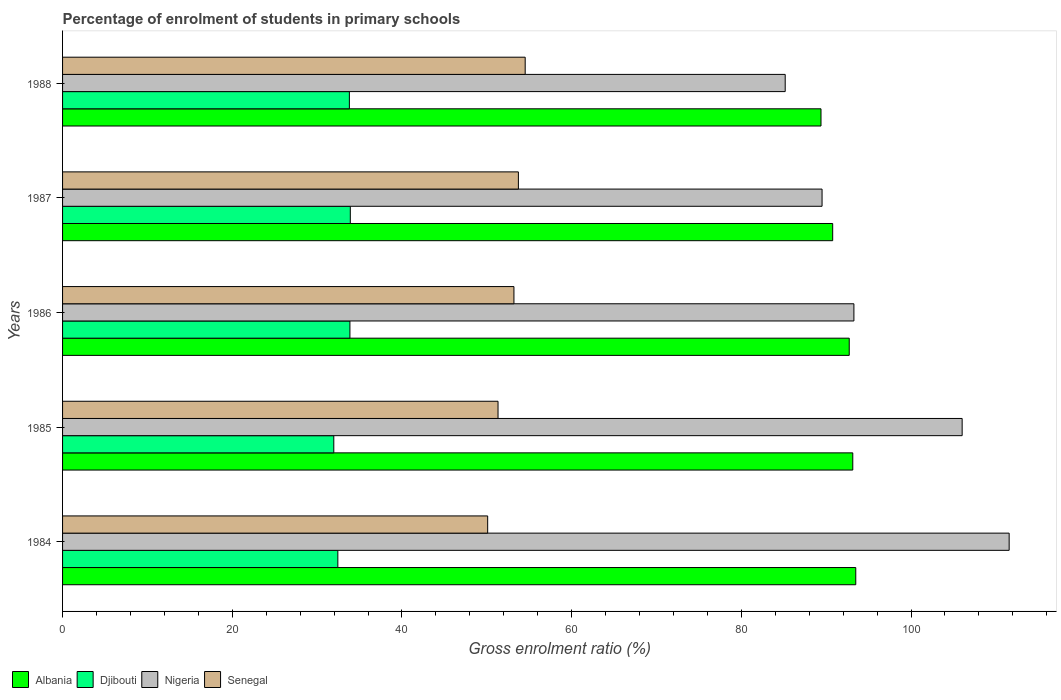How many different coloured bars are there?
Your answer should be compact. 4. Are the number of bars on each tick of the Y-axis equal?
Give a very brief answer. Yes. How many bars are there on the 4th tick from the top?
Your response must be concise. 4. What is the label of the 1st group of bars from the top?
Provide a succinct answer. 1988. What is the percentage of students enrolled in primary schools in Senegal in 1985?
Your response must be concise. 51.32. Across all years, what is the maximum percentage of students enrolled in primary schools in Nigeria?
Give a very brief answer. 111.57. Across all years, what is the minimum percentage of students enrolled in primary schools in Albania?
Ensure brevity in your answer.  89.39. What is the total percentage of students enrolled in primary schools in Senegal in the graph?
Your answer should be very brief. 262.87. What is the difference between the percentage of students enrolled in primary schools in Nigeria in 1984 and that in 1987?
Your answer should be very brief. 22.05. What is the difference between the percentage of students enrolled in primary schools in Djibouti in 1984 and the percentage of students enrolled in primary schools in Nigeria in 1986?
Keep it short and to the point. -60.82. What is the average percentage of students enrolled in primary schools in Senegal per year?
Provide a short and direct response. 52.57. In the year 1986, what is the difference between the percentage of students enrolled in primary schools in Djibouti and percentage of students enrolled in primary schools in Albania?
Give a very brief answer. -58.85. What is the ratio of the percentage of students enrolled in primary schools in Nigeria in 1985 to that in 1986?
Provide a short and direct response. 1.14. Is the percentage of students enrolled in primary schools in Djibouti in 1986 less than that in 1987?
Give a very brief answer. Yes. What is the difference between the highest and the second highest percentage of students enrolled in primary schools in Djibouti?
Make the answer very short. 0.05. What is the difference between the highest and the lowest percentage of students enrolled in primary schools in Senegal?
Offer a very short reply. 4.42. Is the sum of the percentage of students enrolled in primary schools in Nigeria in 1984 and 1988 greater than the maximum percentage of students enrolled in primary schools in Senegal across all years?
Ensure brevity in your answer.  Yes. What does the 3rd bar from the top in 1987 represents?
Your answer should be very brief. Djibouti. What does the 3rd bar from the bottom in 1988 represents?
Your response must be concise. Nigeria. How many bars are there?
Ensure brevity in your answer.  20. Where does the legend appear in the graph?
Provide a succinct answer. Bottom left. How many legend labels are there?
Keep it short and to the point. 4. How are the legend labels stacked?
Ensure brevity in your answer.  Horizontal. What is the title of the graph?
Your answer should be compact. Percentage of enrolment of students in primary schools. Does "Burkina Faso" appear as one of the legend labels in the graph?
Offer a terse response. No. What is the label or title of the X-axis?
Make the answer very short. Gross enrolment ratio (%). What is the Gross enrolment ratio (%) of Albania in 1984?
Provide a short and direct response. 93.49. What is the Gross enrolment ratio (%) of Djibouti in 1984?
Provide a succinct answer. 32.44. What is the Gross enrolment ratio (%) in Nigeria in 1984?
Make the answer very short. 111.57. What is the Gross enrolment ratio (%) of Senegal in 1984?
Provide a short and direct response. 50.1. What is the Gross enrolment ratio (%) of Albania in 1985?
Offer a terse response. 93.13. What is the Gross enrolment ratio (%) of Djibouti in 1985?
Your response must be concise. 31.97. What is the Gross enrolment ratio (%) in Nigeria in 1985?
Make the answer very short. 106.03. What is the Gross enrolment ratio (%) of Senegal in 1985?
Ensure brevity in your answer.  51.32. What is the Gross enrolment ratio (%) in Albania in 1986?
Your answer should be very brief. 92.72. What is the Gross enrolment ratio (%) in Djibouti in 1986?
Ensure brevity in your answer.  33.87. What is the Gross enrolment ratio (%) of Nigeria in 1986?
Keep it short and to the point. 93.27. What is the Gross enrolment ratio (%) in Senegal in 1986?
Your response must be concise. 53.2. What is the Gross enrolment ratio (%) in Albania in 1987?
Keep it short and to the point. 90.77. What is the Gross enrolment ratio (%) in Djibouti in 1987?
Make the answer very short. 33.91. What is the Gross enrolment ratio (%) of Nigeria in 1987?
Keep it short and to the point. 89.51. What is the Gross enrolment ratio (%) in Senegal in 1987?
Provide a succinct answer. 53.72. What is the Gross enrolment ratio (%) in Albania in 1988?
Ensure brevity in your answer.  89.39. What is the Gross enrolment ratio (%) in Djibouti in 1988?
Make the answer very short. 33.8. What is the Gross enrolment ratio (%) of Nigeria in 1988?
Offer a terse response. 85.17. What is the Gross enrolment ratio (%) in Senegal in 1988?
Give a very brief answer. 54.53. Across all years, what is the maximum Gross enrolment ratio (%) in Albania?
Your answer should be compact. 93.49. Across all years, what is the maximum Gross enrolment ratio (%) in Djibouti?
Provide a succinct answer. 33.91. Across all years, what is the maximum Gross enrolment ratio (%) of Nigeria?
Your answer should be compact. 111.57. Across all years, what is the maximum Gross enrolment ratio (%) in Senegal?
Keep it short and to the point. 54.53. Across all years, what is the minimum Gross enrolment ratio (%) of Albania?
Offer a terse response. 89.39. Across all years, what is the minimum Gross enrolment ratio (%) in Djibouti?
Offer a very short reply. 31.97. Across all years, what is the minimum Gross enrolment ratio (%) in Nigeria?
Ensure brevity in your answer.  85.17. Across all years, what is the minimum Gross enrolment ratio (%) in Senegal?
Your response must be concise. 50.1. What is the total Gross enrolment ratio (%) in Albania in the graph?
Provide a short and direct response. 459.49. What is the total Gross enrolment ratio (%) of Djibouti in the graph?
Offer a terse response. 166. What is the total Gross enrolment ratio (%) in Nigeria in the graph?
Provide a succinct answer. 485.54. What is the total Gross enrolment ratio (%) of Senegal in the graph?
Your response must be concise. 262.87. What is the difference between the Gross enrolment ratio (%) of Albania in 1984 and that in 1985?
Provide a succinct answer. 0.35. What is the difference between the Gross enrolment ratio (%) in Djibouti in 1984 and that in 1985?
Provide a short and direct response. 0.48. What is the difference between the Gross enrolment ratio (%) of Nigeria in 1984 and that in 1985?
Ensure brevity in your answer.  5.54. What is the difference between the Gross enrolment ratio (%) in Senegal in 1984 and that in 1985?
Offer a terse response. -1.22. What is the difference between the Gross enrolment ratio (%) in Albania in 1984 and that in 1986?
Offer a terse response. 0.77. What is the difference between the Gross enrolment ratio (%) in Djibouti in 1984 and that in 1986?
Ensure brevity in your answer.  -1.42. What is the difference between the Gross enrolment ratio (%) in Nigeria in 1984 and that in 1986?
Offer a terse response. 18.3. What is the difference between the Gross enrolment ratio (%) of Senegal in 1984 and that in 1986?
Provide a succinct answer. -3.1. What is the difference between the Gross enrolment ratio (%) in Albania in 1984 and that in 1987?
Offer a very short reply. 2.72. What is the difference between the Gross enrolment ratio (%) in Djibouti in 1984 and that in 1987?
Keep it short and to the point. -1.47. What is the difference between the Gross enrolment ratio (%) of Nigeria in 1984 and that in 1987?
Provide a succinct answer. 22.05. What is the difference between the Gross enrolment ratio (%) in Senegal in 1984 and that in 1987?
Make the answer very short. -3.62. What is the difference between the Gross enrolment ratio (%) in Albania in 1984 and that in 1988?
Your answer should be very brief. 4.1. What is the difference between the Gross enrolment ratio (%) of Djibouti in 1984 and that in 1988?
Provide a short and direct response. -1.36. What is the difference between the Gross enrolment ratio (%) in Nigeria in 1984 and that in 1988?
Offer a very short reply. 26.4. What is the difference between the Gross enrolment ratio (%) of Senegal in 1984 and that in 1988?
Provide a succinct answer. -4.42. What is the difference between the Gross enrolment ratio (%) in Albania in 1985 and that in 1986?
Your answer should be very brief. 0.42. What is the difference between the Gross enrolment ratio (%) of Djibouti in 1985 and that in 1986?
Your answer should be very brief. -1.9. What is the difference between the Gross enrolment ratio (%) in Nigeria in 1985 and that in 1986?
Give a very brief answer. 12.76. What is the difference between the Gross enrolment ratio (%) in Senegal in 1985 and that in 1986?
Your answer should be compact. -1.87. What is the difference between the Gross enrolment ratio (%) of Albania in 1985 and that in 1987?
Your answer should be very brief. 2.37. What is the difference between the Gross enrolment ratio (%) of Djibouti in 1985 and that in 1987?
Your answer should be compact. -1.95. What is the difference between the Gross enrolment ratio (%) in Nigeria in 1985 and that in 1987?
Make the answer very short. 16.51. What is the difference between the Gross enrolment ratio (%) in Senegal in 1985 and that in 1987?
Keep it short and to the point. -2.4. What is the difference between the Gross enrolment ratio (%) of Albania in 1985 and that in 1988?
Provide a short and direct response. 3.75. What is the difference between the Gross enrolment ratio (%) of Djibouti in 1985 and that in 1988?
Offer a very short reply. -1.83. What is the difference between the Gross enrolment ratio (%) of Nigeria in 1985 and that in 1988?
Provide a short and direct response. 20.86. What is the difference between the Gross enrolment ratio (%) in Senegal in 1985 and that in 1988?
Keep it short and to the point. -3.2. What is the difference between the Gross enrolment ratio (%) of Albania in 1986 and that in 1987?
Offer a terse response. 1.95. What is the difference between the Gross enrolment ratio (%) in Djibouti in 1986 and that in 1987?
Make the answer very short. -0.05. What is the difference between the Gross enrolment ratio (%) in Nigeria in 1986 and that in 1987?
Ensure brevity in your answer.  3.75. What is the difference between the Gross enrolment ratio (%) of Senegal in 1986 and that in 1987?
Your response must be concise. -0.53. What is the difference between the Gross enrolment ratio (%) of Albania in 1986 and that in 1988?
Offer a terse response. 3.33. What is the difference between the Gross enrolment ratio (%) in Djibouti in 1986 and that in 1988?
Your response must be concise. 0.06. What is the difference between the Gross enrolment ratio (%) of Nigeria in 1986 and that in 1988?
Ensure brevity in your answer.  8.1. What is the difference between the Gross enrolment ratio (%) in Senegal in 1986 and that in 1988?
Provide a succinct answer. -1.33. What is the difference between the Gross enrolment ratio (%) of Albania in 1987 and that in 1988?
Offer a terse response. 1.38. What is the difference between the Gross enrolment ratio (%) in Djibouti in 1987 and that in 1988?
Your response must be concise. 0.11. What is the difference between the Gross enrolment ratio (%) in Nigeria in 1987 and that in 1988?
Make the answer very short. 4.34. What is the difference between the Gross enrolment ratio (%) of Senegal in 1987 and that in 1988?
Offer a terse response. -0.8. What is the difference between the Gross enrolment ratio (%) of Albania in 1984 and the Gross enrolment ratio (%) of Djibouti in 1985?
Make the answer very short. 61.52. What is the difference between the Gross enrolment ratio (%) in Albania in 1984 and the Gross enrolment ratio (%) in Nigeria in 1985?
Your response must be concise. -12.54. What is the difference between the Gross enrolment ratio (%) of Albania in 1984 and the Gross enrolment ratio (%) of Senegal in 1985?
Provide a succinct answer. 42.16. What is the difference between the Gross enrolment ratio (%) of Djibouti in 1984 and the Gross enrolment ratio (%) of Nigeria in 1985?
Keep it short and to the point. -73.58. What is the difference between the Gross enrolment ratio (%) of Djibouti in 1984 and the Gross enrolment ratio (%) of Senegal in 1985?
Your response must be concise. -18.88. What is the difference between the Gross enrolment ratio (%) in Nigeria in 1984 and the Gross enrolment ratio (%) in Senegal in 1985?
Your answer should be compact. 60.24. What is the difference between the Gross enrolment ratio (%) of Albania in 1984 and the Gross enrolment ratio (%) of Djibouti in 1986?
Make the answer very short. 59.62. What is the difference between the Gross enrolment ratio (%) of Albania in 1984 and the Gross enrolment ratio (%) of Nigeria in 1986?
Your answer should be compact. 0.22. What is the difference between the Gross enrolment ratio (%) in Albania in 1984 and the Gross enrolment ratio (%) in Senegal in 1986?
Provide a short and direct response. 40.29. What is the difference between the Gross enrolment ratio (%) of Djibouti in 1984 and the Gross enrolment ratio (%) of Nigeria in 1986?
Offer a very short reply. -60.82. What is the difference between the Gross enrolment ratio (%) of Djibouti in 1984 and the Gross enrolment ratio (%) of Senegal in 1986?
Offer a terse response. -20.75. What is the difference between the Gross enrolment ratio (%) of Nigeria in 1984 and the Gross enrolment ratio (%) of Senegal in 1986?
Keep it short and to the point. 58.37. What is the difference between the Gross enrolment ratio (%) in Albania in 1984 and the Gross enrolment ratio (%) in Djibouti in 1987?
Provide a short and direct response. 59.57. What is the difference between the Gross enrolment ratio (%) in Albania in 1984 and the Gross enrolment ratio (%) in Nigeria in 1987?
Ensure brevity in your answer.  3.97. What is the difference between the Gross enrolment ratio (%) of Albania in 1984 and the Gross enrolment ratio (%) of Senegal in 1987?
Give a very brief answer. 39.76. What is the difference between the Gross enrolment ratio (%) in Djibouti in 1984 and the Gross enrolment ratio (%) in Nigeria in 1987?
Keep it short and to the point. -57.07. What is the difference between the Gross enrolment ratio (%) in Djibouti in 1984 and the Gross enrolment ratio (%) in Senegal in 1987?
Give a very brief answer. -21.28. What is the difference between the Gross enrolment ratio (%) of Nigeria in 1984 and the Gross enrolment ratio (%) of Senegal in 1987?
Offer a very short reply. 57.84. What is the difference between the Gross enrolment ratio (%) in Albania in 1984 and the Gross enrolment ratio (%) in Djibouti in 1988?
Your response must be concise. 59.68. What is the difference between the Gross enrolment ratio (%) of Albania in 1984 and the Gross enrolment ratio (%) of Nigeria in 1988?
Keep it short and to the point. 8.32. What is the difference between the Gross enrolment ratio (%) of Albania in 1984 and the Gross enrolment ratio (%) of Senegal in 1988?
Your answer should be very brief. 38.96. What is the difference between the Gross enrolment ratio (%) of Djibouti in 1984 and the Gross enrolment ratio (%) of Nigeria in 1988?
Offer a very short reply. -52.73. What is the difference between the Gross enrolment ratio (%) of Djibouti in 1984 and the Gross enrolment ratio (%) of Senegal in 1988?
Provide a succinct answer. -22.08. What is the difference between the Gross enrolment ratio (%) in Nigeria in 1984 and the Gross enrolment ratio (%) in Senegal in 1988?
Offer a very short reply. 57.04. What is the difference between the Gross enrolment ratio (%) of Albania in 1985 and the Gross enrolment ratio (%) of Djibouti in 1986?
Your answer should be very brief. 59.27. What is the difference between the Gross enrolment ratio (%) of Albania in 1985 and the Gross enrolment ratio (%) of Nigeria in 1986?
Make the answer very short. -0.13. What is the difference between the Gross enrolment ratio (%) of Albania in 1985 and the Gross enrolment ratio (%) of Senegal in 1986?
Give a very brief answer. 39.94. What is the difference between the Gross enrolment ratio (%) of Djibouti in 1985 and the Gross enrolment ratio (%) of Nigeria in 1986?
Offer a terse response. -61.3. What is the difference between the Gross enrolment ratio (%) in Djibouti in 1985 and the Gross enrolment ratio (%) in Senegal in 1986?
Provide a short and direct response. -21.23. What is the difference between the Gross enrolment ratio (%) of Nigeria in 1985 and the Gross enrolment ratio (%) of Senegal in 1986?
Keep it short and to the point. 52.83. What is the difference between the Gross enrolment ratio (%) of Albania in 1985 and the Gross enrolment ratio (%) of Djibouti in 1987?
Keep it short and to the point. 59.22. What is the difference between the Gross enrolment ratio (%) of Albania in 1985 and the Gross enrolment ratio (%) of Nigeria in 1987?
Provide a succinct answer. 3.62. What is the difference between the Gross enrolment ratio (%) in Albania in 1985 and the Gross enrolment ratio (%) in Senegal in 1987?
Your answer should be compact. 39.41. What is the difference between the Gross enrolment ratio (%) of Djibouti in 1985 and the Gross enrolment ratio (%) of Nigeria in 1987?
Offer a very short reply. -57.55. What is the difference between the Gross enrolment ratio (%) of Djibouti in 1985 and the Gross enrolment ratio (%) of Senegal in 1987?
Give a very brief answer. -21.76. What is the difference between the Gross enrolment ratio (%) in Nigeria in 1985 and the Gross enrolment ratio (%) in Senegal in 1987?
Make the answer very short. 52.3. What is the difference between the Gross enrolment ratio (%) of Albania in 1985 and the Gross enrolment ratio (%) of Djibouti in 1988?
Ensure brevity in your answer.  59.33. What is the difference between the Gross enrolment ratio (%) in Albania in 1985 and the Gross enrolment ratio (%) in Nigeria in 1988?
Offer a terse response. 7.96. What is the difference between the Gross enrolment ratio (%) of Albania in 1985 and the Gross enrolment ratio (%) of Senegal in 1988?
Your answer should be very brief. 38.61. What is the difference between the Gross enrolment ratio (%) of Djibouti in 1985 and the Gross enrolment ratio (%) of Nigeria in 1988?
Offer a terse response. -53.2. What is the difference between the Gross enrolment ratio (%) in Djibouti in 1985 and the Gross enrolment ratio (%) in Senegal in 1988?
Offer a very short reply. -22.56. What is the difference between the Gross enrolment ratio (%) in Nigeria in 1985 and the Gross enrolment ratio (%) in Senegal in 1988?
Keep it short and to the point. 51.5. What is the difference between the Gross enrolment ratio (%) in Albania in 1986 and the Gross enrolment ratio (%) in Djibouti in 1987?
Ensure brevity in your answer.  58.8. What is the difference between the Gross enrolment ratio (%) in Albania in 1986 and the Gross enrolment ratio (%) in Nigeria in 1987?
Your response must be concise. 3.2. What is the difference between the Gross enrolment ratio (%) of Albania in 1986 and the Gross enrolment ratio (%) of Senegal in 1987?
Ensure brevity in your answer.  38.99. What is the difference between the Gross enrolment ratio (%) in Djibouti in 1986 and the Gross enrolment ratio (%) in Nigeria in 1987?
Your answer should be very brief. -55.65. What is the difference between the Gross enrolment ratio (%) of Djibouti in 1986 and the Gross enrolment ratio (%) of Senegal in 1987?
Your answer should be very brief. -19.86. What is the difference between the Gross enrolment ratio (%) in Nigeria in 1986 and the Gross enrolment ratio (%) in Senegal in 1987?
Ensure brevity in your answer.  39.54. What is the difference between the Gross enrolment ratio (%) in Albania in 1986 and the Gross enrolment ratio (%) in Djibouti in 1988?
Give a very brief answer. 58.91. What is the difference between the Gross enrolment ratio (%) in Albania in 1986 and the Gross enrolment ratio (%) in Nigeria in 1988?
Offer a very short reply. 7.55. What is the difference between the Gross enrolment ratio (%) of Albania in 1986 and the Gross enrolment ratio (%) of Senegal in 1988?
Make the answer very short. 38.19. What is the difference between the Gross enrolment ratio (%) of Djibouti in 1986 and the Gross enrolment ratio (%) of Nigeria in 1988?
Your response must be concise. -51.3. What is the difference between the Gross enrolment ratio (%) of Djibouti in 1986 and the Gross enrolment ratio (%) of Senegal in 1988?
Your answer should be compact. -20.66. What is the difference between the Gross enrolment ratio (%) in Nigeria in 1986 and the Gross enrolment ratio (%) in Senegal in 1988?
Ensure brevity in your answer.  38.74. What is the difference between the Gross enrolment ratio (%) in Albania in 1987 and the Gross enrolment ratio (%) in Djibouti in 1988?
Offer a very short reply. 56.96. What is the difference between the Gross enrolment ratio (%) in Albania in 1987 and the Gross enrolment ratio (%) in Nigeria in 1988?
Give a very brief answer. 5.59. What is the difference between the Gross enrolment ratio (%) in Albania in 1987 and the Gross enrolment ratio (%) in Senegal in 1988?
Offer a very short reply. 36.24. What is the difference between the Gross enrolment ratio (%) in Djibouti in 1987 and the Gross enrolment ratio (%) in Nigeria in 1988?
Your response must be concise. -51.26. What is the difference between the Gross enrolment ratio (%) in Djibouti in 1987 and the Gross enrolment ratio (%) in Senegal in 1988?
Make the answer very short. -20.61. What is the difference between the Gross enrolment ratio (%) of Nigeria in 1987 and the Gross enrolment ratio (%) of Senegal in 1988?
Offer a terse response. 34.99. What is the average Gross enrolment ratio (%) of Albania per year?
Keep it short and to the point. 91.9. What is the average Gross enrolment ratio (%) of Djibouti per year?
Offer a very short reply. 33.2. What is the average Gross enrolment ratio (%) in Nigeria per year?
Offer a very short reply. 97.11. What is the average Gross enrolment ratio (%) in Senegal per year?
Your answer should be very brief. 52.57. In the year 1984, what is the difference between the Gross enrolment ratio (%) in Albania and Gross enrolment ratio (%) in Djibouti?
Your response must be concise. 61.04. In the year 1984, what is the difference between the Gross enrolment ratio (%) in Albania and Gross enrolment ratio (%) in Nigeria?
Keep it short and to the point. -18.08. In the year 1984, what is the difference between the Gross enrolment ratio (%) of Albania and Gross enrolment ratio (%) of Senegal?
Offer a very short reply. 43.38. In the year 1984, what is the difference between the Gross enrolment ratio (%) of Djibouti and Gross enrolment ratio (%) of Nigeria?
Provide a succinct answer. -79.12. In the year 1984, what is the difference between the Gross enrolment ratio (%) in Djibouti and Gross enrolment ratio (%) in Senegal?
Ensure brevity in your answer.  -17.66. In the year 1984, what is the difference between the Gross enrolment ratio (%) in Nigeria and Gross enrolment ratio (%) in Senegal?
Ensure brevity in your answer.  61.46. In the year 1985, what is the difference between the Gross enrolment ratio (%) in Albania and Gross enrolment ratio (%) in Djibouti?
Provide a succinct answer. 61.17. In the year 1985, what is the difference between the Gross enrolment ratio (%) in Albania and Gross enrolment ratio (%) in Nigeria?
Keep it short and to the point. -12.89. In the year 1985, what is the difference between the Gross enrolment ratio (%) of Albania and Gross enrolment ratio (%) of Senegal?
Your response must be concise. 41.81. In the year 1985, what is the difference between the Gross enrolment ratio (%) of Djibouti and Gross enrolment ratio (%) of Nigeria?
Your response must be concise. -74.06. In the year 1985, what is the difference between the Gross enrolment ratio (%) of Djibouti and Gross enrolment ratio (%) of Senegal?
Your answer should be compact. -19.36. In the year 1985, what is the difference between the Gross enrolment ratio (%) in Nigeria and Gross enrolment ratio (%) in Senegal?
Make the answer very short. 54.7. In the year 1986, what is the difference between the Gross enrolment ratio (%) of Albania and Gross enrolment ratio (%) of Djibouti?
Your answer should be compact. 58.85. In the year 1986, what is the difference between the Gross enrolment ratio (%) of Albania and Gross enrolment ratio (%) of Nigeria?
Your answer should be compact. -0.55. In the year 1986, what is the difference between the Gross enrolment ratio (%) in Albania and Gross enrolment ratio (%) in Senegal?
Offer a terse response. 39.52. In the year 1986, what is the difference between the Gross enrolment ratio (%) in Djibouti and Gross enrolment ratio (%) in Nigeria?
Ensure brevity in your answer.  -59.4. In the year 1986, what is the difference between the Gross enrolment ratio (%) of Djibouti and Gross enrolment ratio (%) of Senegal?
Provide a short and direct response. -19.33. In the year 1986, what is the difference between the Gross enrolment ratio (%) in Nigeria and Gross enrolment ratio (%) in Senegal?
Offer a terse response. 40.07. In the year 1987, what is the difference between the Gross enrolment ratio (%) of Albania and Gross enrolment ratio (%) of Djibouti?
Keep it short and to the point. 56.85. In the year 1987, what is the difference between the Gross enrolment ratio (%) in Albania and Gross enrolment ratio (%) in Nigeria?
Your response must be concise. 1.25. In the year 1987, what is the difference between the Gross enrolment ratio (%) in Albania and Gross enrolment ratio (%) in Senegal?
Your answer should be compact. 37.04. In the year 1987, what is the difference between the Gross enrolment ratio (%) of Djibouti and Gross enrolment ratio (%) of Nigeria?
Provide a succinct answer. -55.6. In the year 1987, what is the difference between the Gross enrolment ratio (%) in Djibouti and Gross enrolment ratio (%) in Senegal?
Make the answer very short. -19.81. In the year 1987, what is the difference between the Gross enrolment ratio (%) of Nigeria and Gross enrolment ratio (%) of Senegal?
Make the answer very short. 35.79. In the year 1988, what is the difference between the Gross enrolment ratio (%) of Albania and Gross enrolment ratio (%) of Djibouti?
Make the answer very short. 55.59. In the year 1988, what is the difference between the Gross enrolment ratio (%) in Albania and Gross enrolment ratio (%) in Nigeria?
Provide a succinct answer. 4.22. In the year 1988, what is the difference between the Gross enrolment ratio (%) of Albania and Gross enrolment ratio (%) of Senegal?
Your answer should be very brief. 34.86. In the year 1988, what is the difference between the Gross enrolment ratio (%) of Djibouti and Gross enrolment ratio (%) of Nigeria?
Keep it short and to the point. -51.37. In the year 1988, what is the difference between the Gross enrolment ratio (%) of Djibouti and Gross enrolment ratio (%) of Senegal?
Provide a succinct answer. -20.72. In the year 1988, what is the difference between the Gross enrolment ratio (%) in Nigeria and Gross enrolment ratio (%) in Senegal?
Provide a short and direct response. 30.65. What is the ratio of the Gross enrolment ratio (%) in Albania in 1984 to that in 1985?
Keep it short and to the point. 1. What is the ratio of the Gross enrolment ratio (%) in Djibouti in 1984 to that in 1985?
Provide a succinct answer. 1.01. What is the ratio of the Gross enrolment ratio (%) in Nigeria in 1984 to that in 1985?
Provide a short and direct response. 1.05. What is the ratio of the Gross enrolment ratio (%) of Senegal in 1984 to that in 1985?
Offer a very short reply. 0.98. What is the ratio of the Gross enrolment ratio (%) in Albania in 1984 to that in 1986?
Make the answer very short. 1.01. What is the ratio of the Gross enrolment ratio (%) in Djibouti in 1984 to that in 1986?
Give a very brief answer. 0.96. What is the ratio of the Gross enrolment ratio (%) in Nigeria in 1984 to that in 1986?
Ensure brevity in your answer.  1.2. What is the ratio of the Gross enrolment ratio (%) in Senegal in 1984 to that in 1986?
Your answer should be compact. 0.94. What is the ratio of the Gross enrolment ratio (%) in Djibouti in 1984 to that in 1987?
Offer a terse response. 0.96. What is the ratio of the Gross enrolment ratio (%) of Nigeria in 1984 to that in 1987?
Ensure brevity in your answer.  1.25. What is the ratio of the Gross enrolment ratio (%) of Senegal in 1984 to that in 1987?
Provide a short and direct response. 0.93. What is the ratio of the Gross enrolment ratio (%) in Albania in 1984 to that in 1988?
Keep it short and to the point. 1.05. What is the ratio of the Gross enrolment ratio (%) of Djibouti in 1984 to that in 1988?
Give a very brief answer. 0.96. What is the ratio of the Gross enrolment ratio (%) of Nigeria in 1984 to that in 1988?
Keep it short and to the point. 1.31. What is the ratio of the Gross enrolment ratio (%) in Senegal in 1984 to that in 1988?
Your response must be concise. 0.92. What is the ratio of the Gross enrolment ratio (%) of Djibouti in 1985 to that in 1986?
Keep it short and to the point. 0.94. What is the ratio of the Gross enrolment ratio (%) in Nigeria in 1985 to that in 1986?
Offer a terse response. 1.14. What is the ratio of the Gross enrolment ratio (%) of Senegal in 1985 to that in 1986?
Offer a terse response. 0.96. What is the ratio of the Gross enrolment ratio (%) in Albania in 1985 to that in 1987?
Your answer should be very brief. 1.03. What is the ratio of the Gross enrolment ratio (%) in Djibouti in 1985 to that in 1987?
Provide a succinct answer. 0.94. What is the ratio of the Gross enrolment ratio (%) in Nigeria in 1985 to that in 1987?
Offer a terse response. 1.18. What is the ratio of the Gross enrolment ratio (%) of Senegal in 1985 to that in 1987?
Ensure brevity in your answer.  0.96. What is the ratio of the Gross enrolment ratio (%) of Albania in 1985 to that in 1988?
Ensure brevity in your answer.  1.04. What is the ratio of the Gross enrolment ratio (%) in Djibouti in 1985 to that in 1988?
Provide a succinct answer. 0.95. What is the ratio of the Gross enrolment ratio (%) in Nigeria in 1985 to that in 1988?
Provide a short and direct response. 1.24. What is the ratio of the Gross enrolment ratio (%) of Senegal in 1985 to that in 1988?
Make the answer very short. 0.94. What is the ratio of the Gross enrolment ratio (%) of Albania in 1986 to that in 1987?
Provide a succinct answer. 1.02. What is the ratio of the Gross enrolment ratio (%) in Nigeria in 1986 to that in 1987?
Keep it short and to the point. 1.04. What is the ratio of the Gross enrolment ratio (%) of Senegal in 1986 to that in 1987?
Offer a terse response. 0.99. What is the ratio of the Gross enrolment ratio (%) of Albania in 1986 to that in 1988?
Your answer should be very brief. 1.04. What is the ratio of the Gross enrolment ratio (%) in Djibouti in 1986 to that in 1988?
Give a very brief answer. 1. What is the ratio of the Gross enrolment ratio (%) in Nigeria in 1986 to that in 1988?
Your answer should be very brief. 1.1. What is the ratio of the Gross enrolment ratio (%) of Senegal in 1986 to that in 1988?
Your answer should be very brief. 0.98. What is the ratio of the Gross enrolment ratio (%) of Albania in 1987 to that in 1988?
Keep it short and to the point. 1.02. What is the ratio of the Gross enrolment ratio (%) in Nigeria in 1987 to that in 1988?
Your response must be concise. 1.05. What is the difference between the highest and the second highest Gross enrolment ratio (%) of Albania?
Keep it short and to the point. 0.35. What is the difference between the highest and the second highest Gross enrolment ratio (%) in Djibouti?
Give a very brief answer. 0.05. What is the difference between the highest and the second highest Gross enrolment ratio (%) in Nigeria?
Offer a terse response. 5.54. What is the difference between the highest and the second highest Gross enrolment ratio (%) in Senegal?
Give a very brief answer. 0.8. What is the difference between the highest and the lowest Gross enrolment ratio (%) in Albania?
Your answer should be compact. 4.1. What is the difference between the highest and the lowest Gross enrolment ratio (%) in Djibouti?
Offer a very short reply. 1.95. What is the difference between the highest and the lowest Gross enrolment ratio (%) in Nigeria?
Make the answer very short. 26.4. What is the difference between the highest and the lowest Gross enrolment ratio (%) in Senegal?
Offer a terse response. 4.42. 